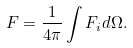<formula> <loc_0><loc_0><loc_500><loc_500>F = \frac { 1 } { 4 \pi } \int F _ { i } d \Omega .</formula> 